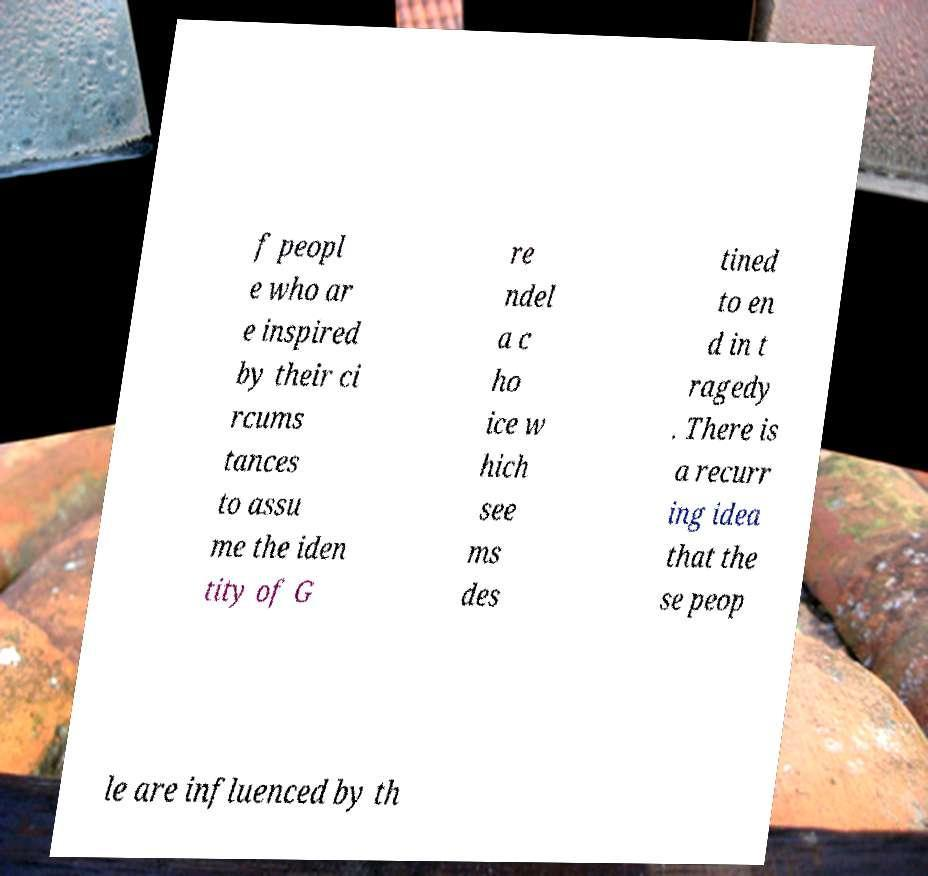Please read and relay the text visible in this image. What does it say? f peopl e who ar e inspired by their ci rcums tances to assu me the iden tity of G re ndel a c ho ice w hich see ms des tined to en d in t ragedy . There is a recurr ing idea that the se peop le are influenced by th 